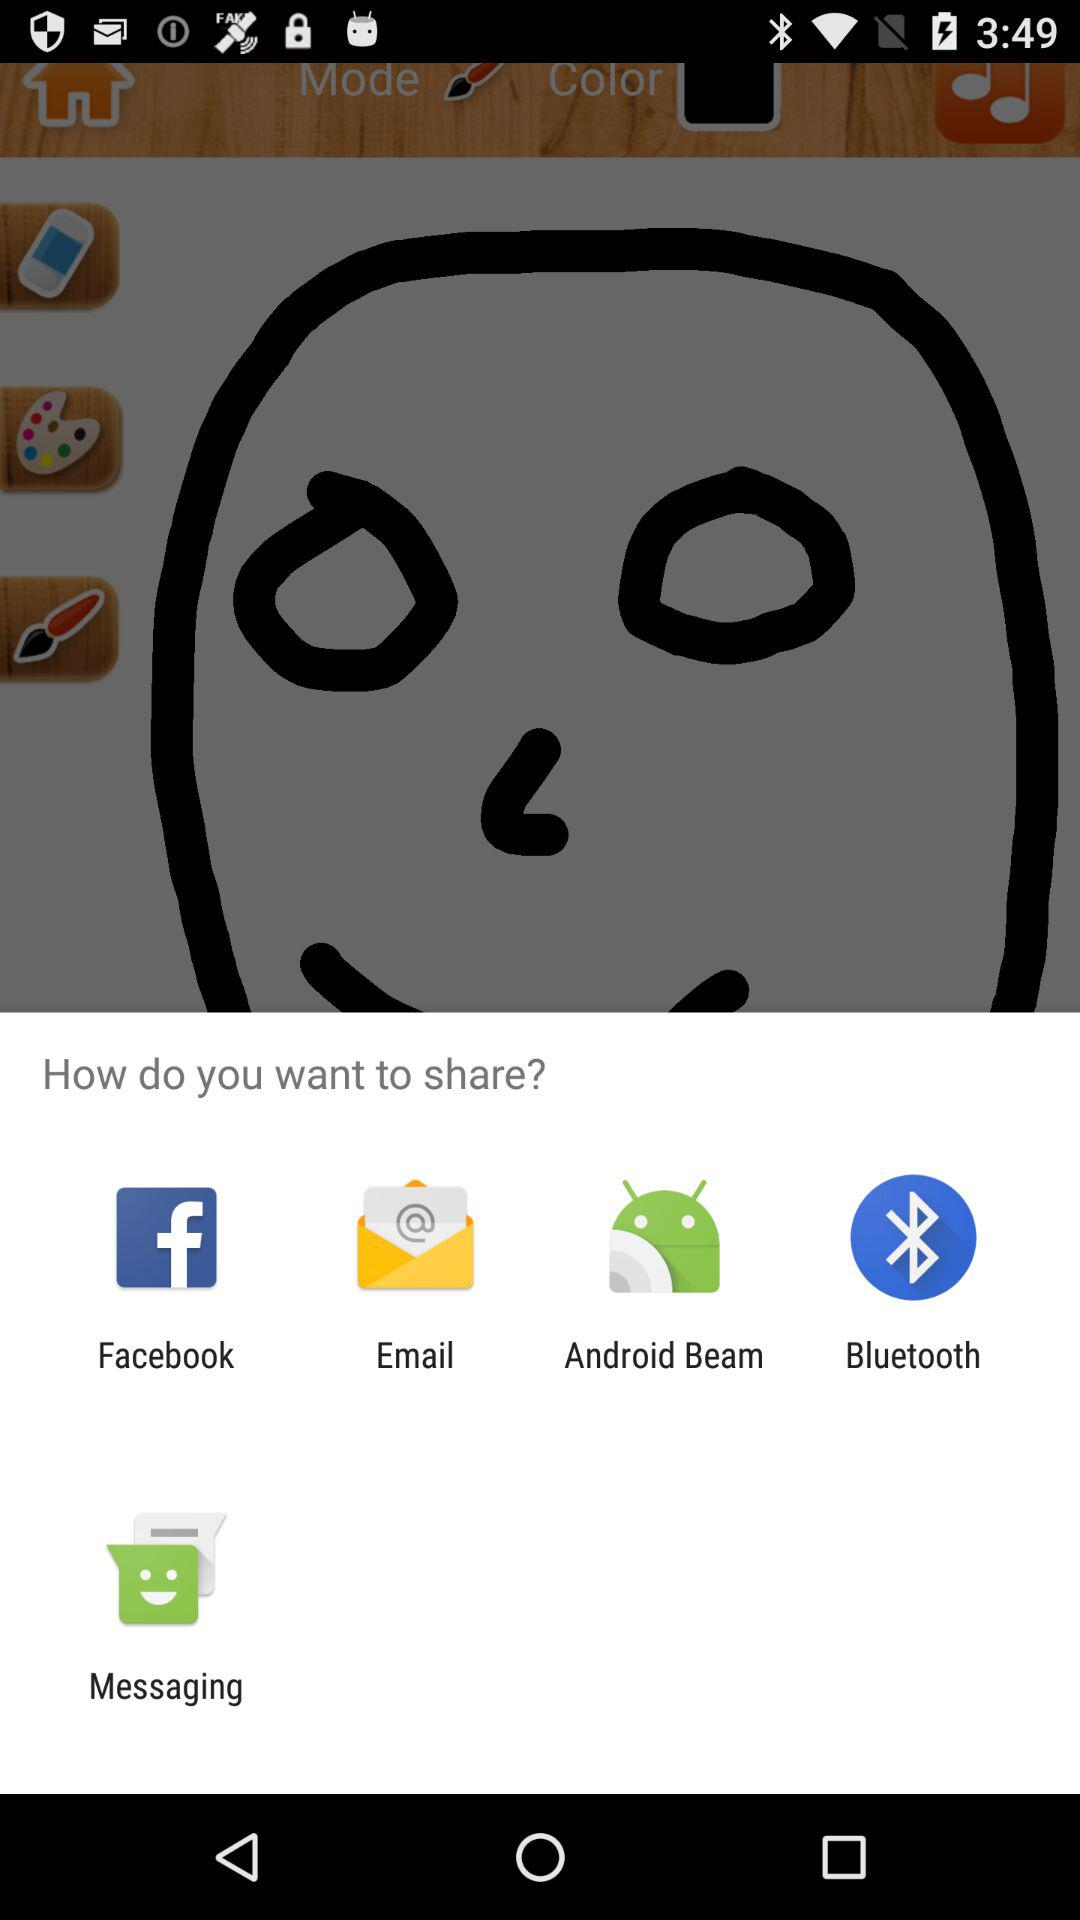What are the sharing options? The sharing options are "Facebook", "Email", "Android Beam", "Bluetooth" and "Messaging". 